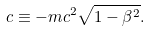Convert formula to latex. <formula><loc_0><loc_0><loc_500><loc_500>\L c \equiv - m c ^ { 2 } \sqrt { 1 - \beta ^ { 2 } } .</formula> 